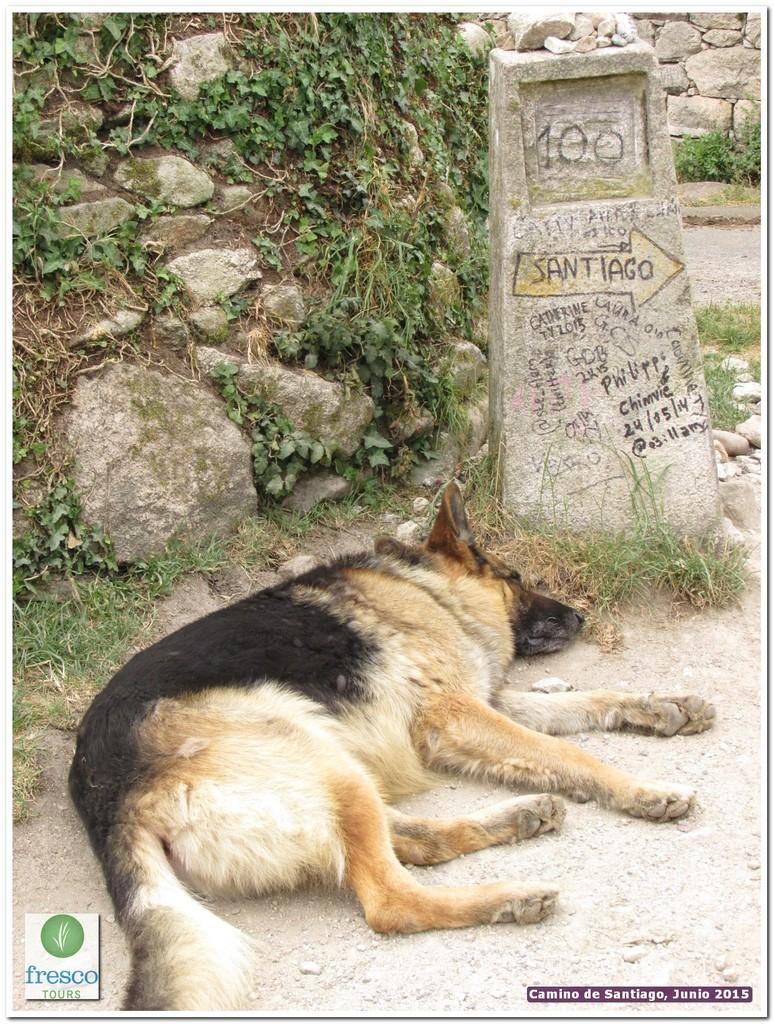What type of animal is present in the image? There is a dog in the image. What structure with text can be seen in the image? There is a stone pillar with text in the image. What type of ground surface is visible in the image? There is grass on the ground in the image. What type of material is present in the image besides the grass? There are stones and plants visible in the image. What type of architectural feature can be seen in the background of the image? There is a stone wall in the background of the image. Can you tell me how many lakes are visible in the image? There are no lakes visible in the image. What type of cream is being used to decorate the stone wall in the image? There is no cream present in the image, and the stone wall does not appear to be decorated. 